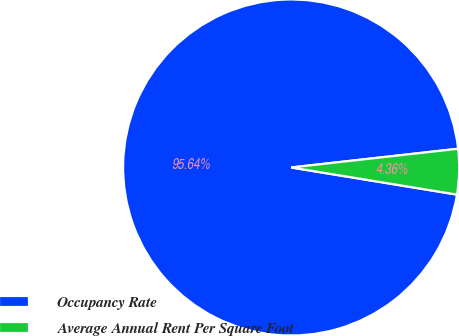Convert chart to OTSL. <chart><loc_0><loc_0><loc_500><loc_500><pie_chart><fcel>Occupancy Rate<fcel>Average Annual Rent Per Square Foot<nl><fcel>95.64%<fcel>4.36%<nl></chart> 